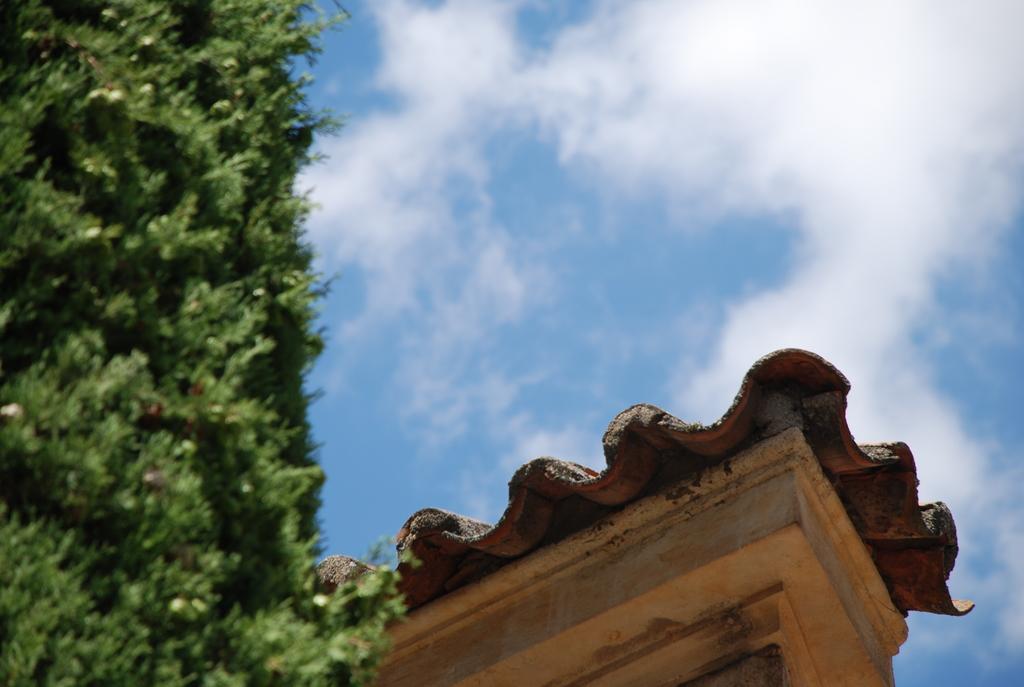Please provide a concise description of this image. In this image we can see the roof and the blue sky with clouds in the background. This part of the image is blurred, where we can see the trees. 